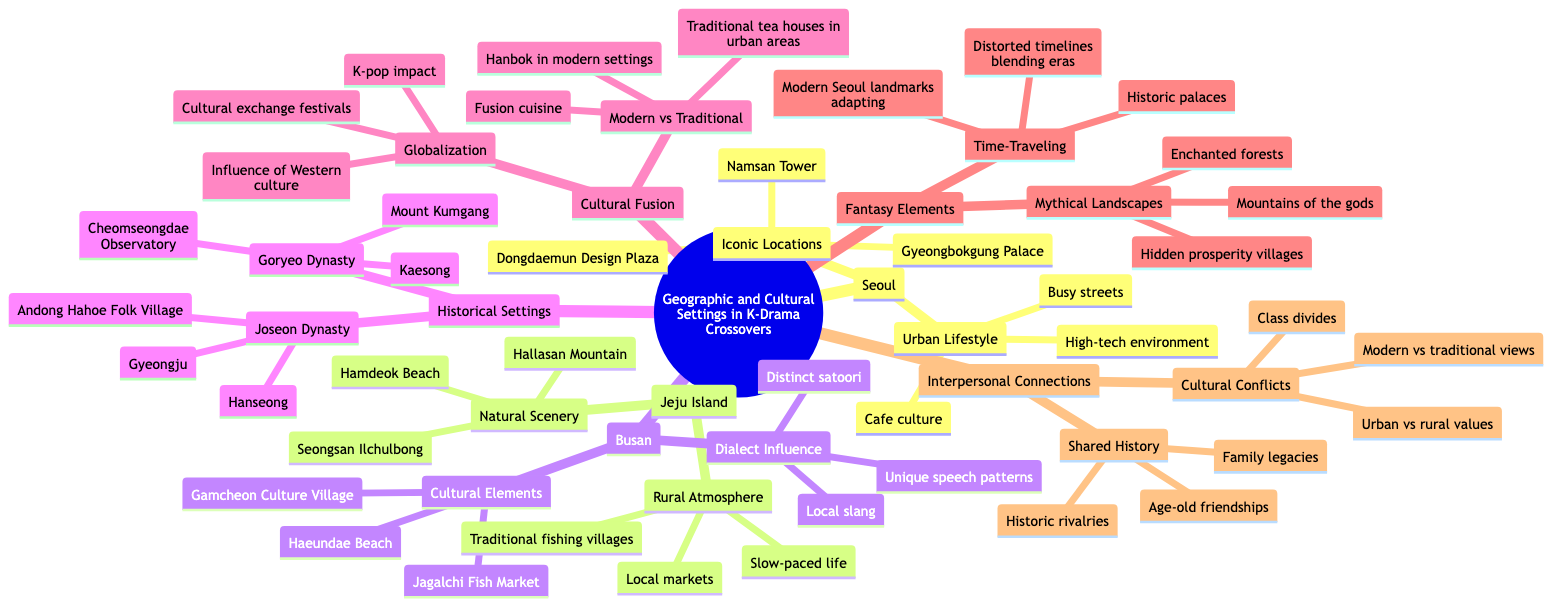What are three iconic locations in Seoul? The diagram lists the iconic locations under the Seoul node, which includes Namsan Tower, Gyeongbokgung Palace, and Dongdaemun Design Plaza.
Answer: Namsan Tower, Gyeongbokgung Palace, Dongdaemun Design Plaza Which island is known for its natural scenery? The Jeju Island node directly indicates it is associated with natural scenery such as Hallasan Mountain, Seongsan Ilchulbong, and Hamdeok Beach.
Answer: Jeju Island How many cultural elements are listed for Busan? The diagram under the Busan node mentions three cultural elements: Jagalchi Fish Market, Haeundae Beach, and Gamcheon Culture Village, making the total three.
Answer: 3 What are two influences of globalization mentioned in the cultural fusion section? Looking at the Cultural Fusion node, the Globalization subsection includes influences such as "Influence of Western culture" and "Cultural exchange festivals".
Answer: Influence of Western culture, Cultural exchange festivals Which historical setting represents the Joseon Dynasty? The Historical Settings node lists descriptions under the Joseon Dynasty category, specifically mentioning Hanseong, Gyeongju, and Andong Hahoe Folk Village.
Answer: Hanseong What type of atmosphere does Jeju Island provide? Under the Jeju Island node, the Rural Atmosphere subsection indicates a "Slow-paced life," which signifies the type of atmosphere in that region.
Answer: Slow-paced life What connects cultural conflicts in the interpersonal connections section? The Interpersonal Connections node highlights Cultural Conflicts including "Urban vs rural values" and "Modern vs traditional views" that depict connections in cultural conflicts.
Answer: Urban vs rural values, Modern vs traditional views How do the fantasy elements describe time-traveling? The Fantasy Elements node includes a Time-Traveling subsection with descriptions like "Historic palaces" and "Modern Seoul landmarks adapting," showing the theme of time-traveling.
Answer: Historic palaces, Modern Seoul landmarks adapting What is a notable natural feature of Jeju Island? The Natural Scenery aspect of Jeju Island denotes Hallasan Mountain as a notable feature, distinguishing it from urban locations.
Answer: Hallasan Mountain 